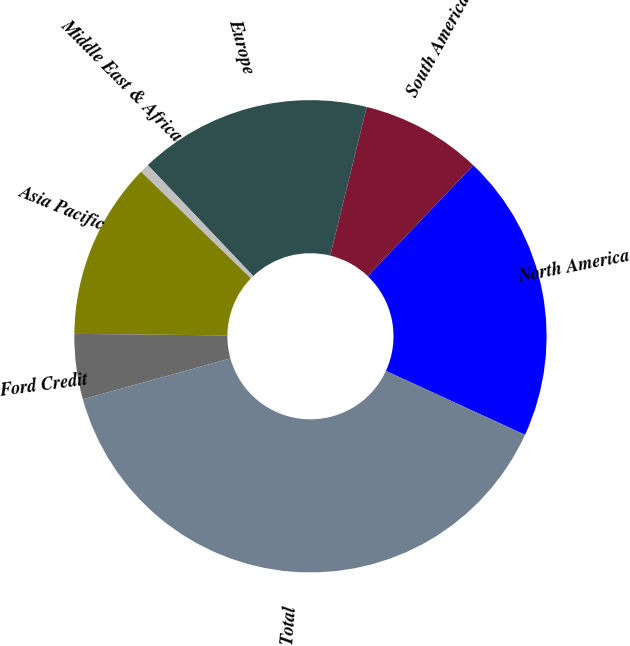<chart> <loc_0><loc_0><loc_500><loc_500><pie_chart><fcel>North America<fcel>South America<fcel>Europe<fcel>Middle East & Africa<fcel>Asia Pacific<fcel>Ford Credit<fcel>Total<nl><fcel>19.74%<fcel>8.28%<fcel>15.92%<fcel>0.64%<fcel>12.1%<fcel>4.46%<fcel>38.84%<nl></chart> 